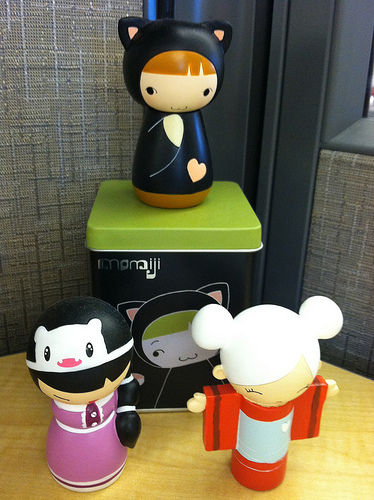<image>
Is there a toy on the tin? No. The toy is not positioned on the tin. They may be near each other, but the toy is not supported by or resting on top of the tin. Is the doll on the doll? No. The doll is not positioned on the doll. They may be near each other, but the doll is not supported by or resting on top of the doll. 